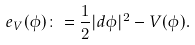Convert formula to latex. <formula><loc_0><loc_0><loc_500><loc_500>e _ { V } ( \phi ) \colon = \frac { 1 } { 2 } | d \phi | ^ { 2 } - V ( \phi ) .</formula> 